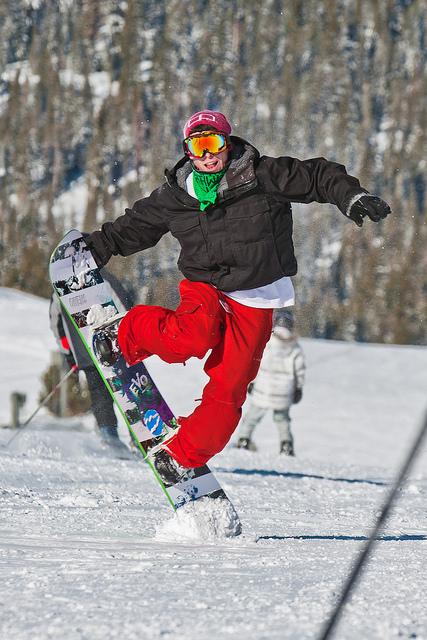What sport is this?
Give a very brief answer. Snowboarding. What color is his bandana?
Give a very brief answer. Green. What color are the persons pants?
Quick response, please. Red. 